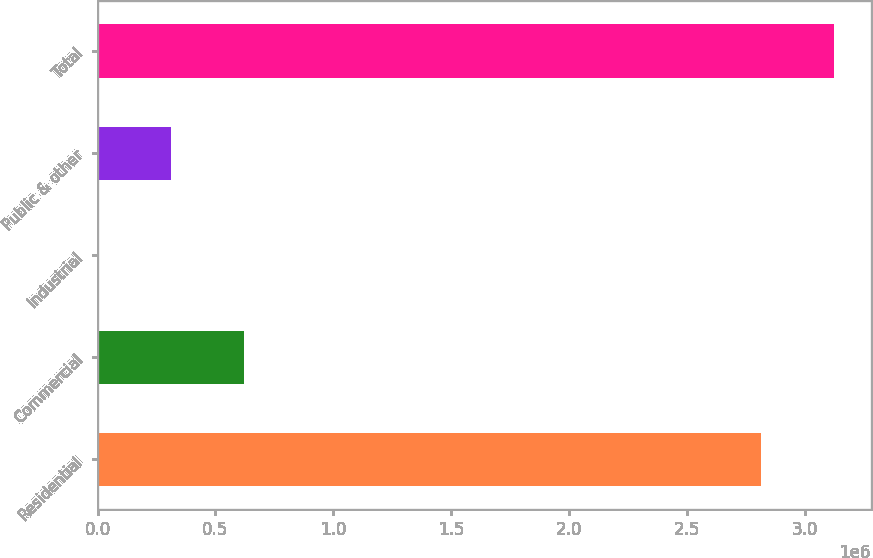Convert chart. <chart><loc_0><loc_0><loc_500><loc_500><bar_chart><fcel>Residential<fcel>Commercial<fcel>Industrial<fcel>Public & other<fcel>Total<nl><fcel>2.81372e+06<fcel>622049<fcel>3793<fcel>312921<fcel>3.12284e+06<nl></chart> 